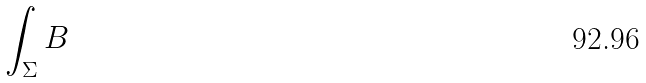Convert formula to latex. <formula><loc_0><loc_0><loc_500><loc_500>\int _ { \Sigma } B</formula> 